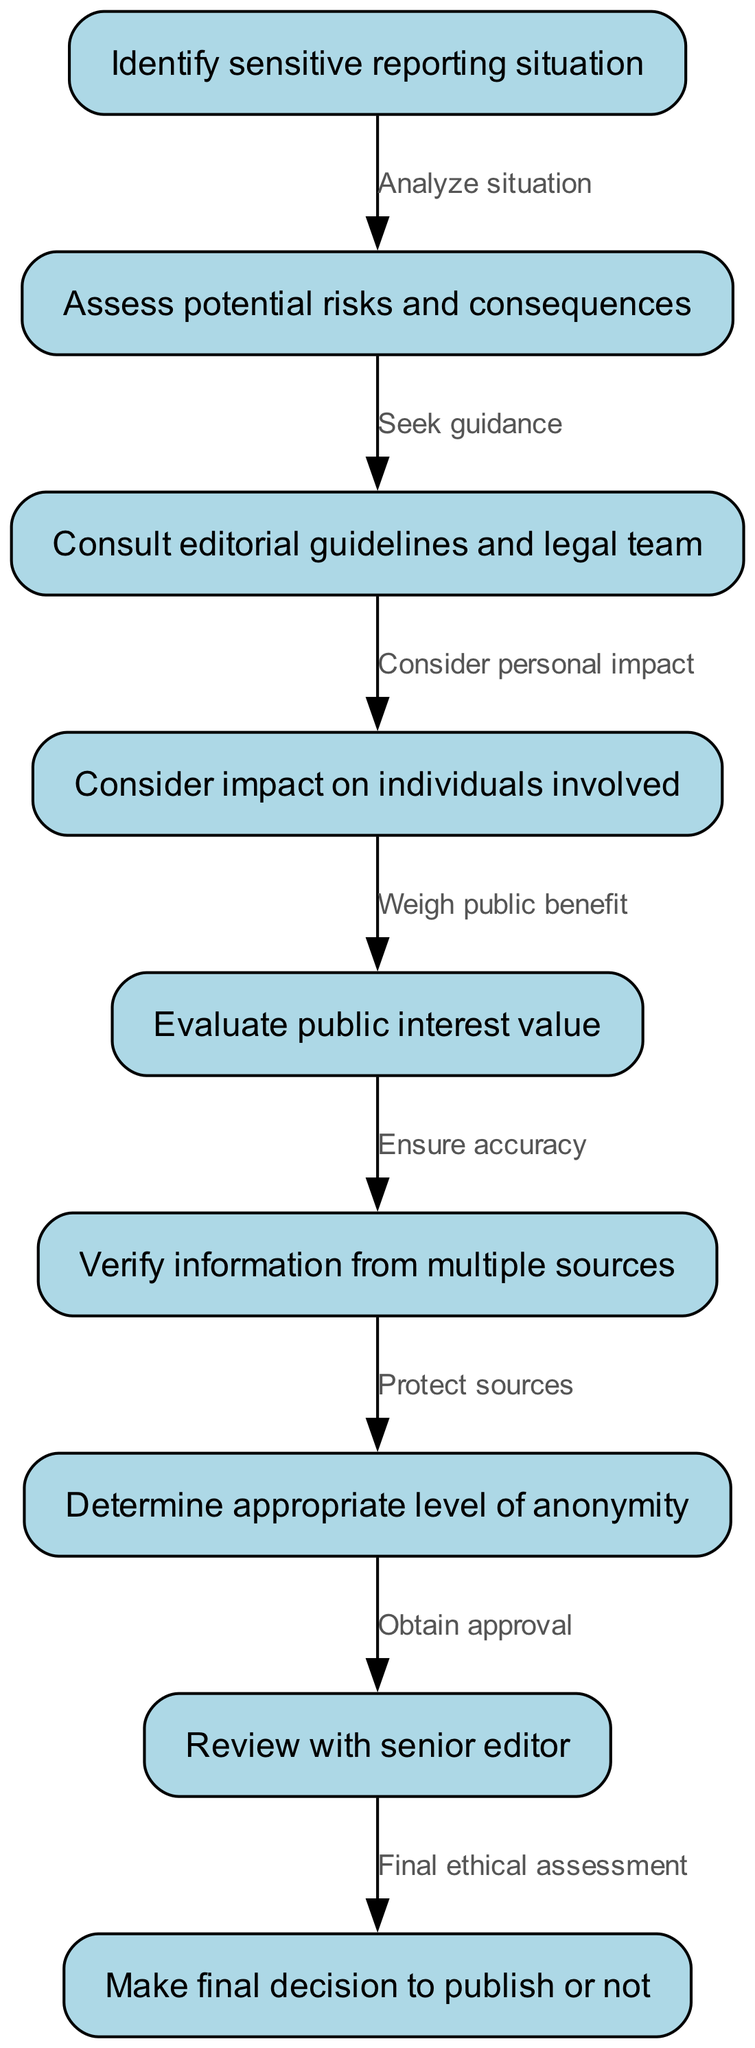What is the first step in the diagram? The first step in the diagram is "Identify sensitive reporting situation," which is represented as the starting node.
Answer: Identify sensitive reporting situation How many nodes are in the diagram? The diagram has a total of nine nodes, each representing a step in the ethical decision-making process.
Answer: Nine What node is reached after "Assess potential risks and consequences"? After "Assess potential risks and consequences," the next node is "Consult editorial guidelines and legal team." This is indicated by the directed edge connecting these two nodes.
Answer: Consult editorial guidelines and legal team What is the last step before making the final decision to publish or not? The last step before making the final decision is "Review with senior editor," which is the second-to-last node preceding the final decision node.
Answer: Review with senior editor What is the relationship between "Verify information from multiple sources" and "Consider impact on individuals involved"? "Verify information from multiple sources" follows "Evaluate public interest value," while "Consider impact on individuals involved" is a part of assessing potential risks and consequences. Therefore, they are connected through the sequence of evaluation but not directly related to one another in terms of sequence.
Answer: No direct relationship What are the two key factors considered before "Evaluate public interest value"? Before "Evaluate public interest value," two key factors considered are "Consider impact on individuals involved" and "Consult editorial guidelines and legal team." These two steps precede the evaluation of public interest and form part of the overall consideration process.
Answer: Consider impact on individuals involved, Consult editorial guidelines and legal team How is anonymity determined in the process? Anonymity is determined after verifying information from multiple sources. The flow indicates the need to protect sources, which leads to the determination of the appropriate level of anonymity.
Answer: Determine appropriate level of anonymity Which step directly involves consulting a senior editor? The step that directly involves consulting a senior editor is "Review with senior editor." This indicates a critical point where the ethical considerations are further assessed.
Answer: Review with senior editor 